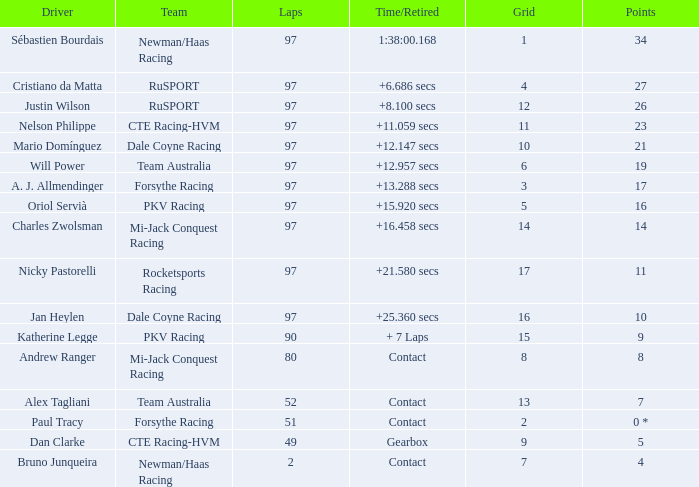What is the highest number of laps for the driver with 5 points? 49.0. 